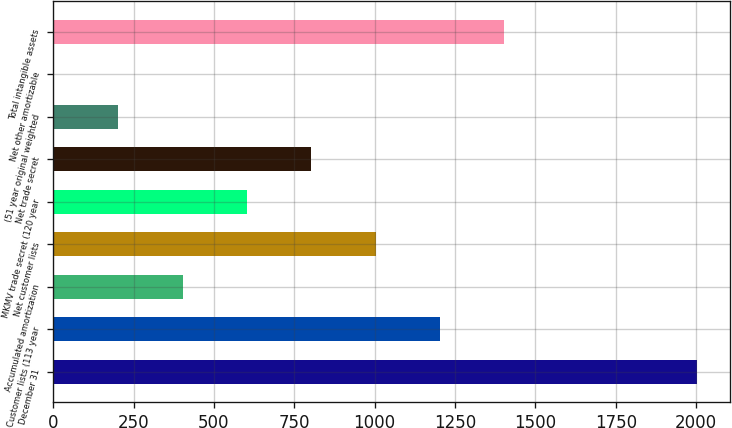Convert chart to OTSL. <chart><loc_0><loc_0><loc_500><loc_500><bar_chart><fcel>December 31<fcel>Customer lists (113 year<fcel>Accumulated amortization<fcel>Net customer lists<fcel>MKMV trade secret (120 year<fcel>Net trade secret<fcel>(51 year original weighted<fcel>Net other amortizable<fcel>Total intangible assets<nl><fcel>2004<fcel>1203.64<fcel>403.28<fcel>1003.55<fcel>603.37<fcel>803.46<fcel>203.19<fcel>3.1<fcel>1403.73<nl></chart> 